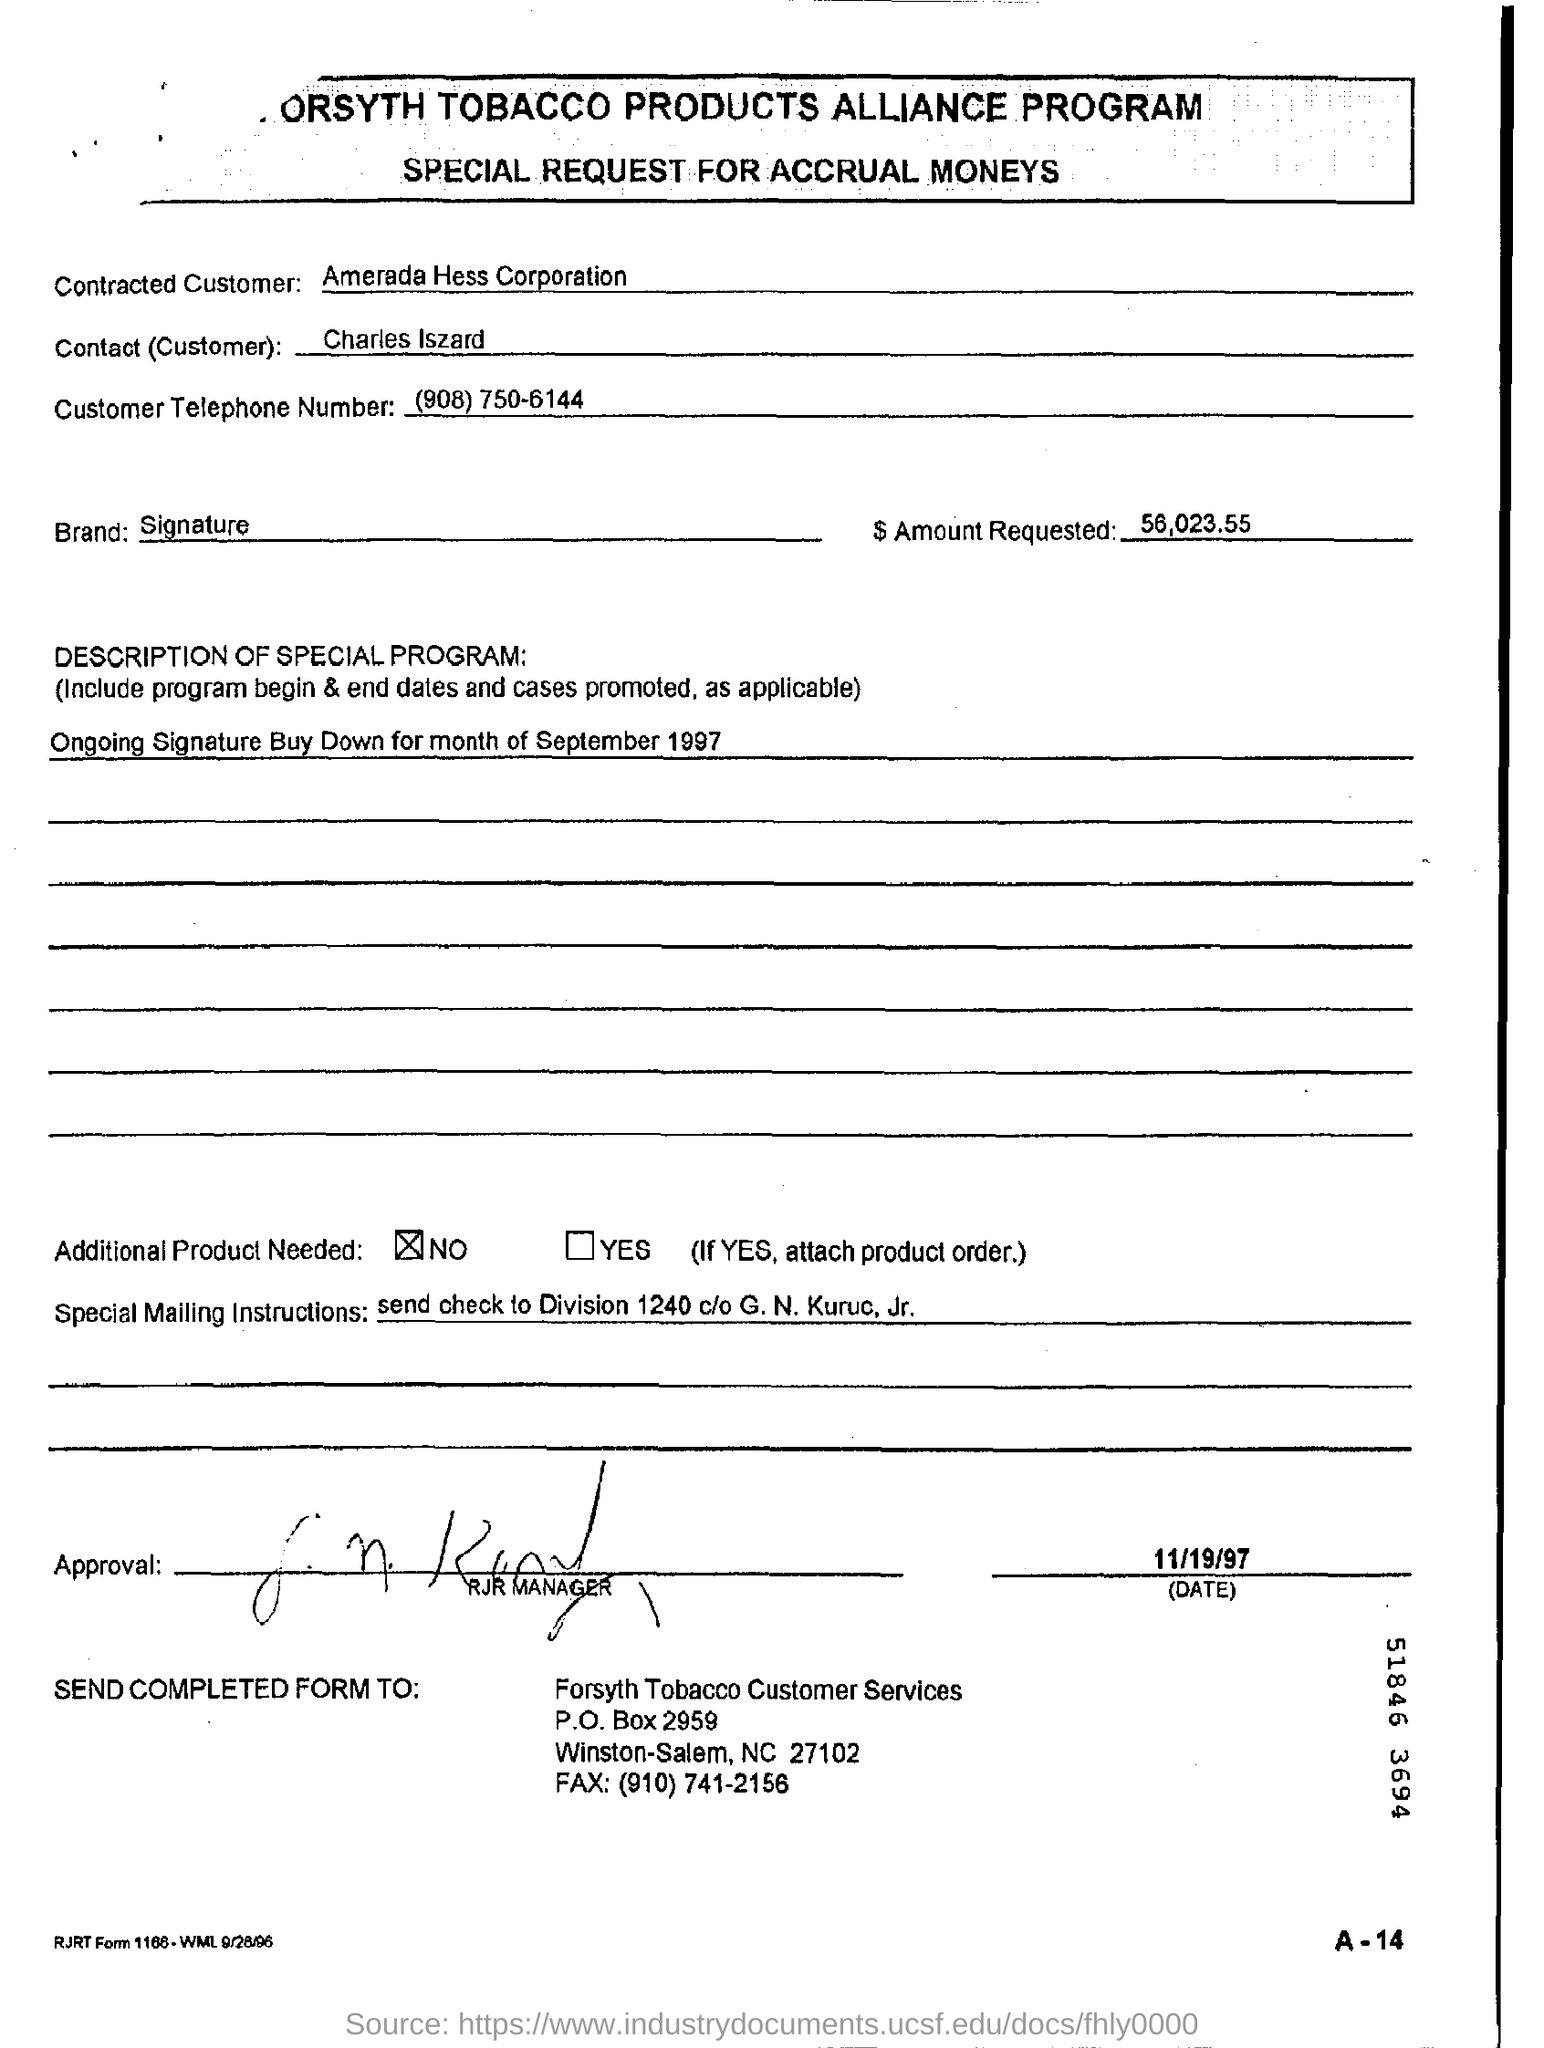Point out several critical features in this image. The Brand's signature style is... The document, with a date of 11/19/97, states... The amount requested is $56,023.55. Amerada Hess Corporation is the contracted customer. The customer's telephone number is (908)750-6144. 